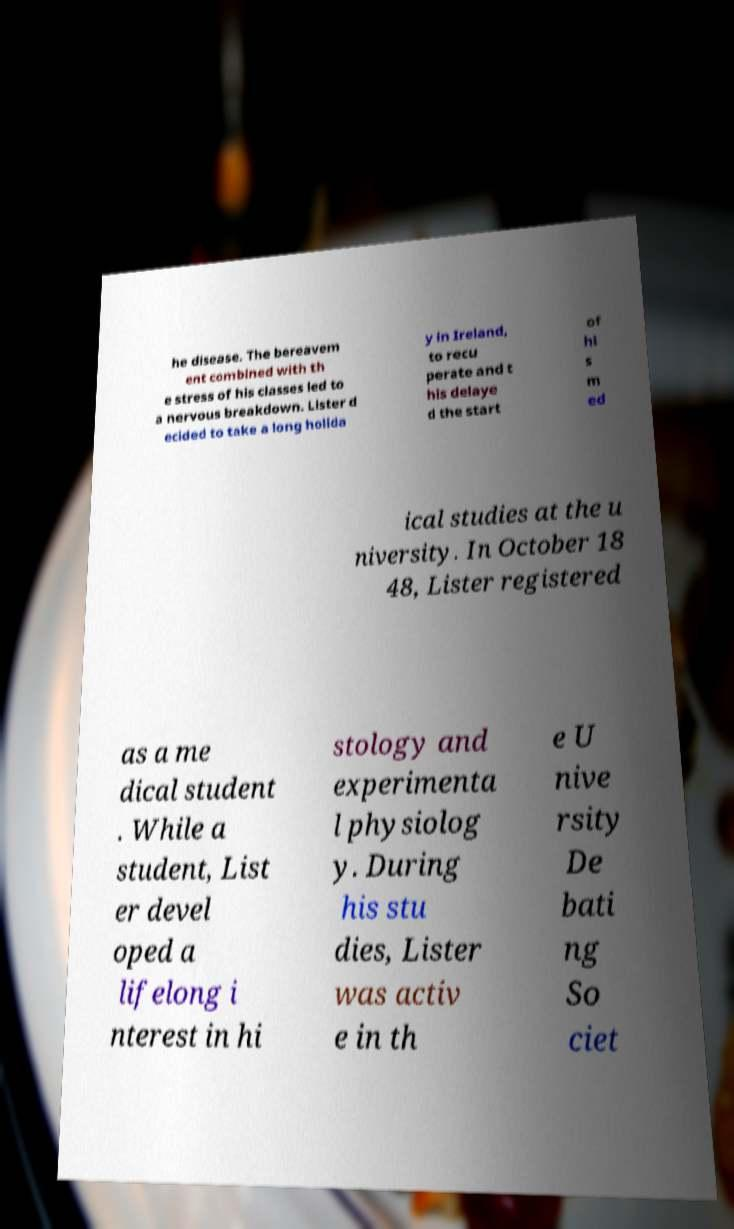Could you extract and type out the text from this image? he disease. The bereavem ent combined with th e stress of his classes led to a nervous breakdown. Lister d ecided to take a long holida y in Ireland, to recu perate and t his delaye d the start of hi s m ed ical studies at the u niversity. In October 18 48, Lister registered as a me dical student . While a student, List er devel oped a lifelong i nterest in hi stology and experimenta l physiolog y. During his stu dies, Lister was activ e in th e U nive rsity De bati ng So ciet 